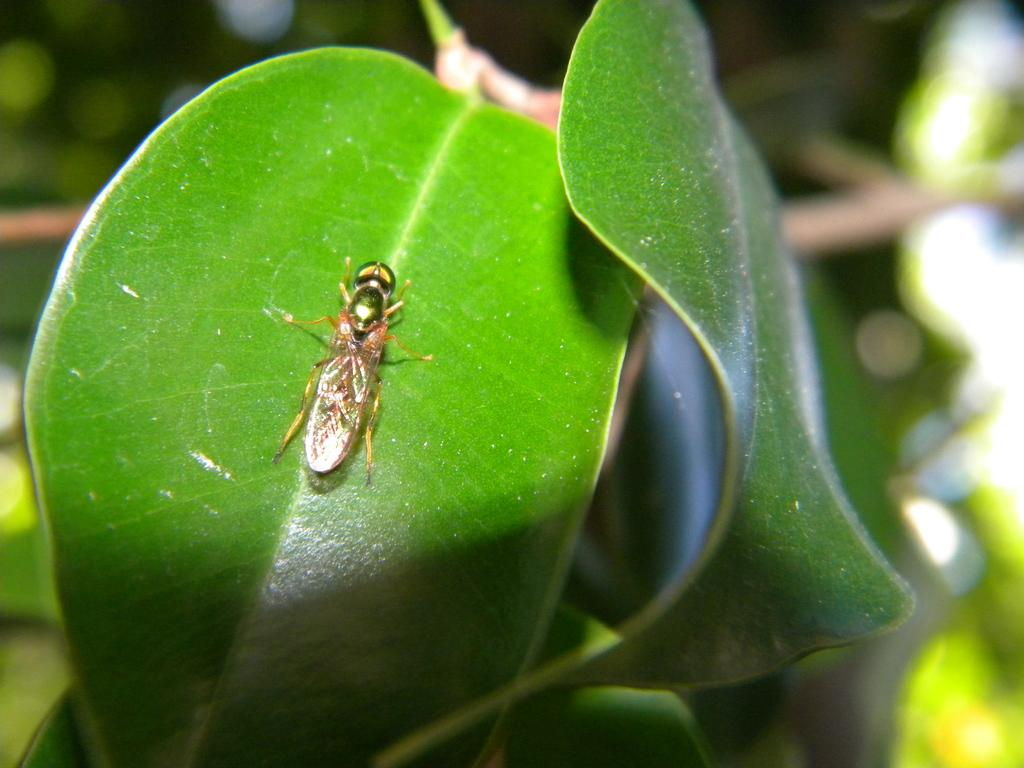How many leaves are present in the image? There are two leaves in the image. What is the color of the leaves? The leaves are green in color. Is there anything else present on the leaves? Yes, there is an insect on one of the leaves. Can you describe the background of the image? The background of the image is blurry. Who is the owner of the game and tent in the image? There is no game or tent present in the image, so there is no owner to be mentioned. 